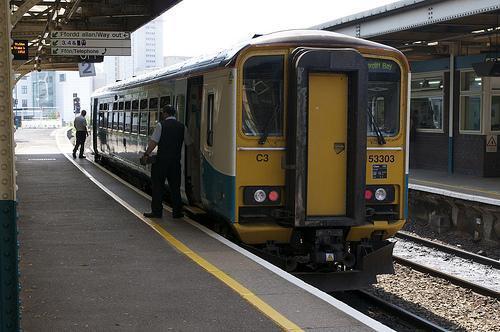How many people are there?
Give a very brief answer. 2. 